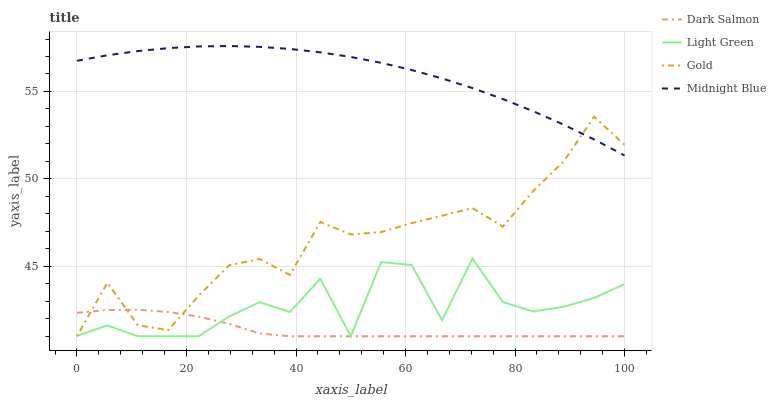Does Dark Salmon have the minimum area under the curve?
Answer yes or no. Yes. Does Midnight Blue have the maximum area under the curve?
Answer yes or no. Yes. Does Light Green have the minimum area under the curve?
Answer yes or no. No. Does Light Green have the maximum area under the curve?
Answer yes or no. No. Is Midnight Blue the smoothest?
Answer yes or no. Yes. Is Light Green the roughest?
Answer yes or no. Yes. Is Dark Salmon the smoothest?
Answer yes or no. No. Is Dark Salmon the roughest?
Answer yes or no. No. Does Gold have the lowest value?
Answer yes or no. Yes. Does Midnight Blue have the lowest value?
Answer yes or no. No. Does Midnight Blue have the highest value?
Answer yes or no. Yes. Does Light Green have the highest value?
Answer yes or no. No. Is Dark Salmon less than Midnight Blue?
Answer yes or no. Yes. Is Midnight Blue greater than Dark Salmon?
Answer yes or no. Yes. Does Gold intersect Dark Salmon?
Answer yes or no. Yes. Is Gold less than Dark Salmon?
Answer yes or no. No. Is Gold greater than Dark Salmon?
Answer yes or no. No. Does Dark Salmon intersect Midnight Blue?
Answer yes or no. No. 